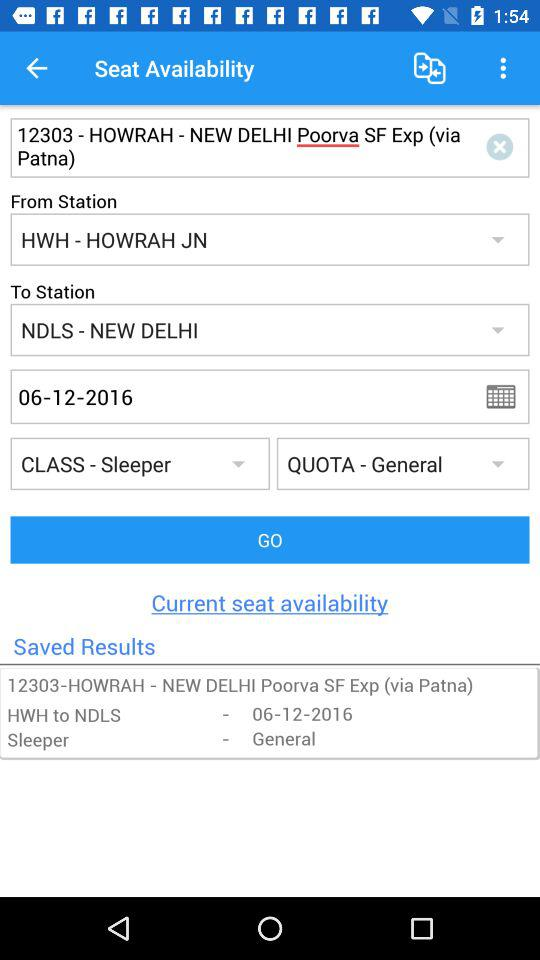Which is the selected booking quota? The selected booking quota is "General". 